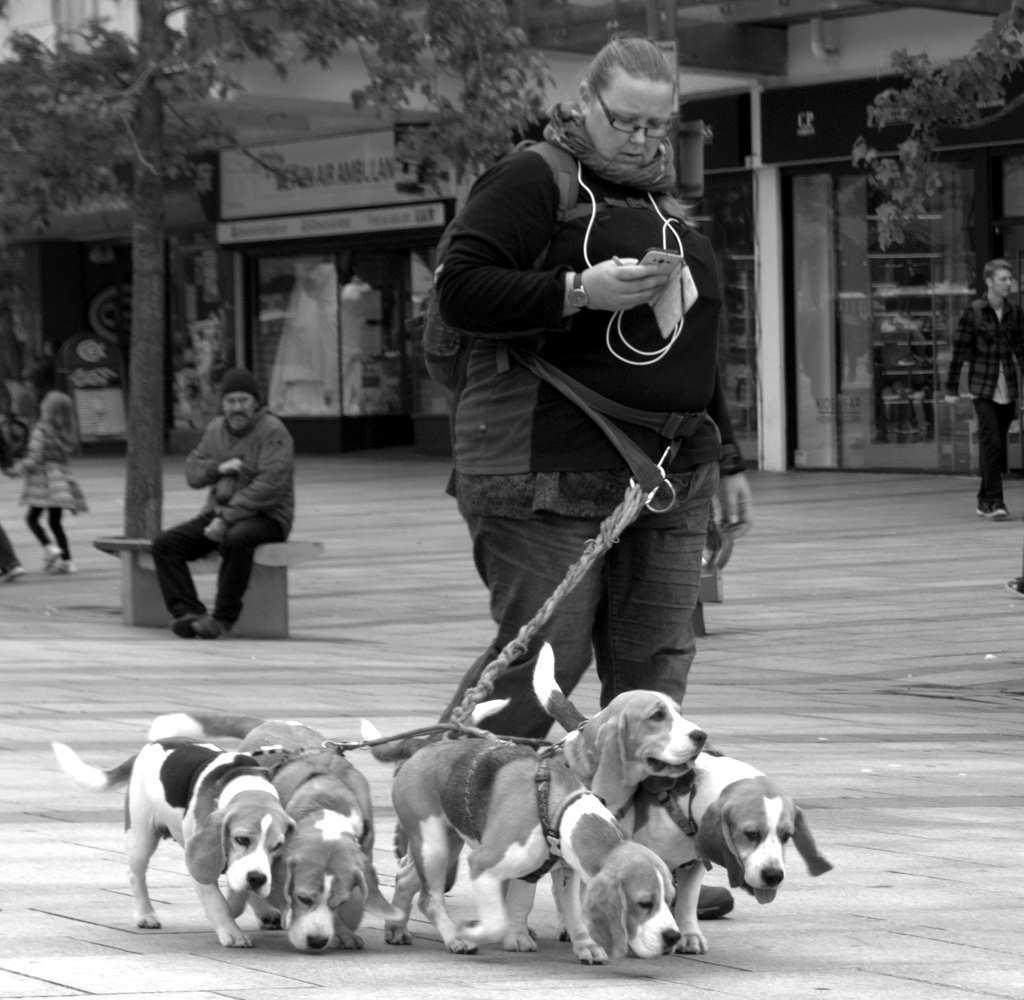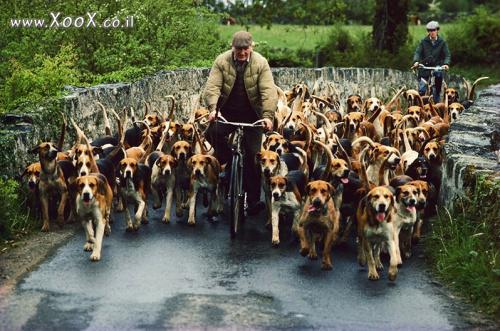The first image is the image on the left, the second image is the image on the right. Analyze the images presented: Is the assertion "In one image, fox hunters are on horses with a pack of hounds." valid? Answer yes or no. No. 